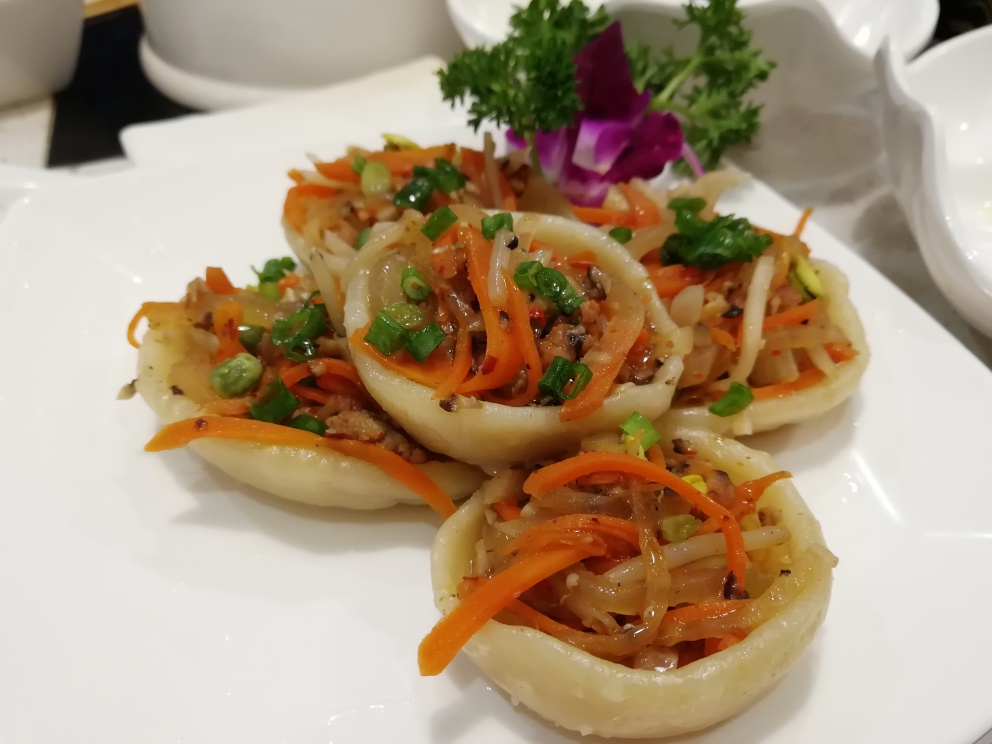What type of cuisine does this dish represent, and can you describe the ingredients present? This dish appears to be an Asian cuisine, possibly Chinese. It looks like stir-fried vegetables and minced meat served inside translucent onion rings, garnished with green peas and carrots. The ingredients suggest a mix of savory and sweet flavors, often characteristic of Asian cooking styles. Could you suggest a beverage that would pair well with this meal? A light jasmine tea or a crisp white wine like Sauvignon Blanc would complement the delicate flavors of this dish without overpowering them. 